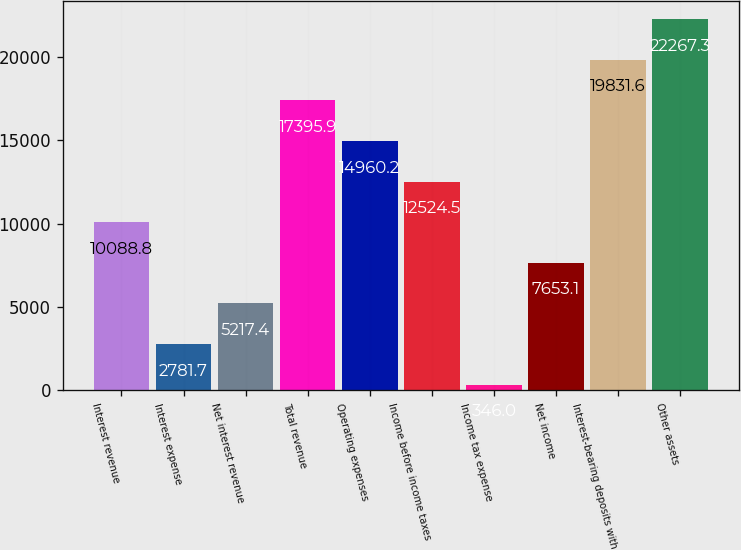Convert chart. <chart><loc_0><loc_0><loc_500><loc_500><bar_chart><fcel>Interest revenue<fcel>Interest expense<fcel>Net interest revenue<fcel>Total revenue<fcel>Operating expenses<fcel>Income before income taxes<fcel>Income tax expense<fcel>Net income<fcel>Interest-bearing deposits with<fcel>Other assets<nl><fcel>10088.8<fcel>2781.7<fcel>5217.4<fcel>17395.9<fcel>14960.2<fcel>12524.5<fcel>346<fcel>7653.1<fcel>19831.6<fcel>22267.3<nl></chart> 